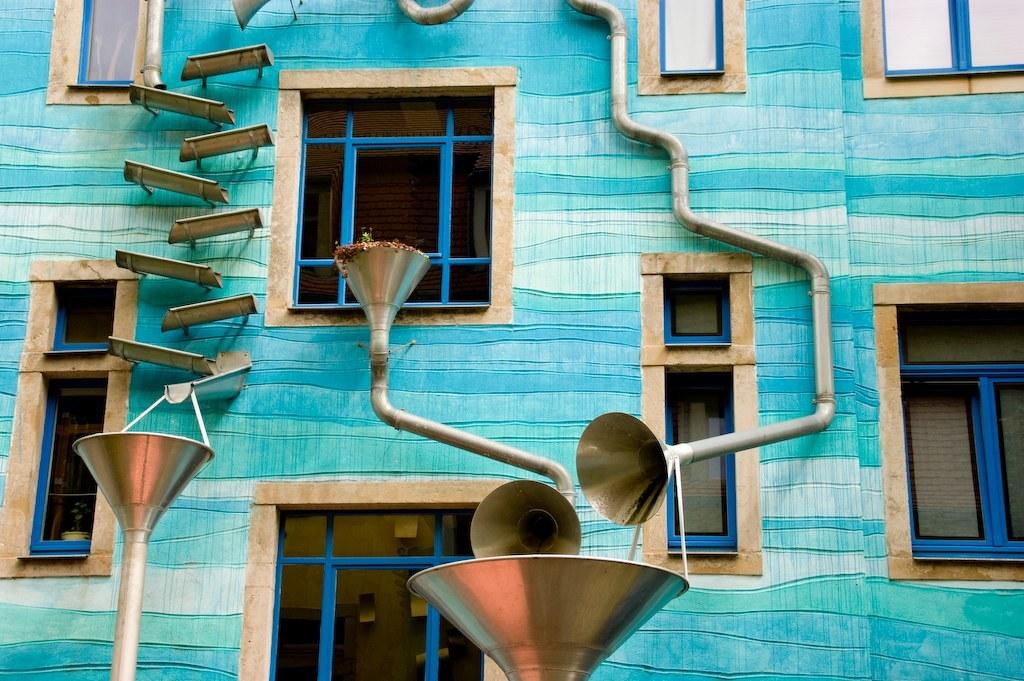What type of structure is visible in the image? There is a building in the image. What feature can be seen on the building? The building has windows. What else can be seen in the image besides the building? There are pipes, other items on the wall, and funnel-shaped objects in the image. Which direction is the building facing in the image? The provided facts do not indicate the direction the building is facing in the image. Is there a lamp hanging from the ceiling in the image? There is no mention of a lamp in the image, so it cannot be determined if one is present. 